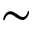<formula> <loc_0><loc_0><loc_500><loc_500>\sim</formula> 